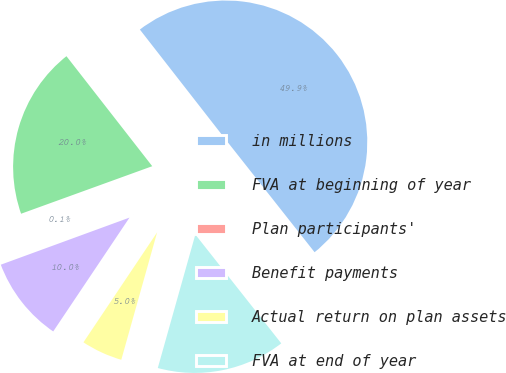<chart> <loc_0><loc_0><loc_500><loc_500><pie_chart><fcel>in millions<fcel>FVA at beginning of year<fcel>Plan participants'<fcel>Benefit payments<fcel>Actual return on plan assets<fcel>FVA at end of year<nl><fcel>49.9%<fcel>19.99%<fcel>0.05%<fcel>10.02%<fcel>5.03%<fcel>15.0%<nl></chart> 